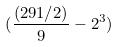<formula> <loc_0><loc_0><loc_500><loc_500>( \frac { ( 2 9 1 / 2 ) } { 9 } - 2 ^ { 3 } )</formula> 